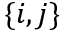Convert formula to latex. <formula><loc_0><loc_0><loc_500><loc_500>\{ i , j \}</formula> 